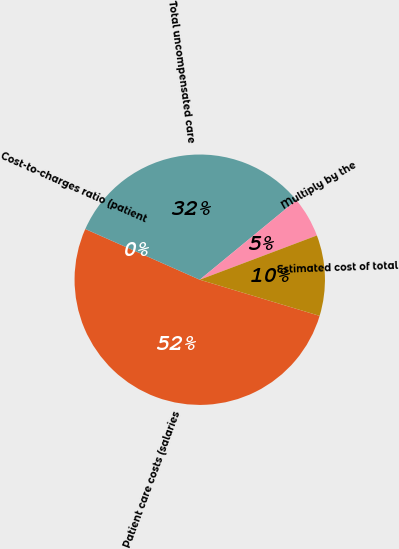Convert chart. <chart><loc_0><loc_0><loc_500><loc_500><pie_chart><fcel>Patient care costs (salaries<fcel>Cost-to-charges ratio (patient<fcel>Total uncompensated care<fcel>Multiply by the<fcel>Estimated cost of total<nl><fcel>51.96%<fcel>0.02%<fcel>32.4%<fcel>5.21%<fcel>10.41%<nl></chart> 